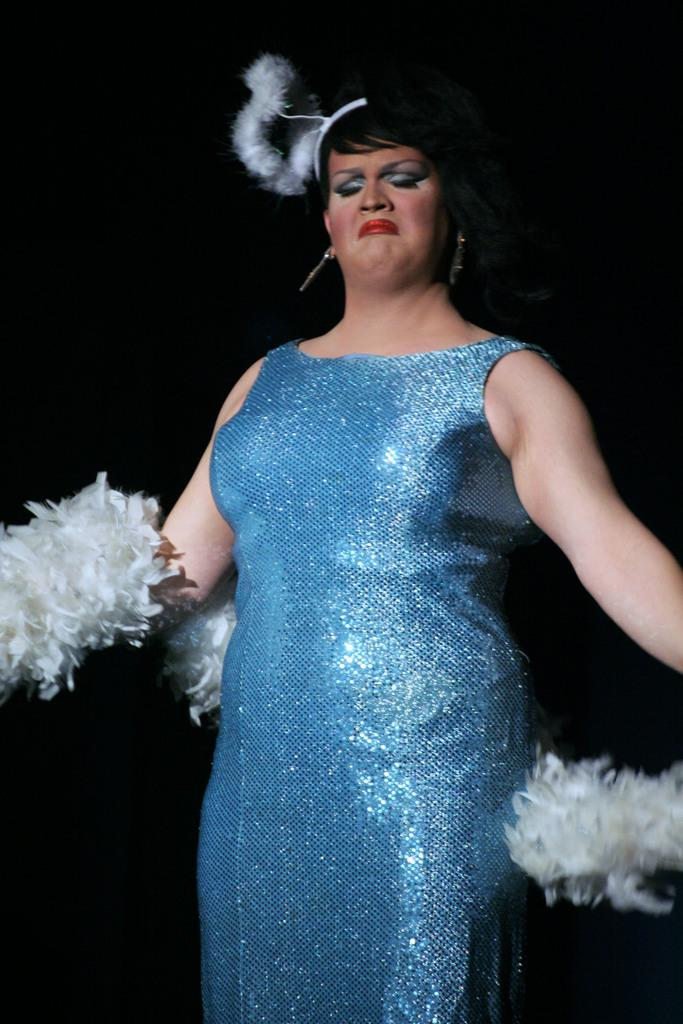Who is the main subject in the image? There is a woman in the image. What is the woman wearing? The woman is wearing a blue dress. What is the woman holding in her hand? The woman is holding something in her hand, but the specific object is not mentioned in the facts. What is the woman doing in the image? The woman is dancing. How would you describe the lighting in the image? The background of the image appears to be dark. What type of account does the woman have in the image? There is no mention of an account in the image or the provided facts. --- 